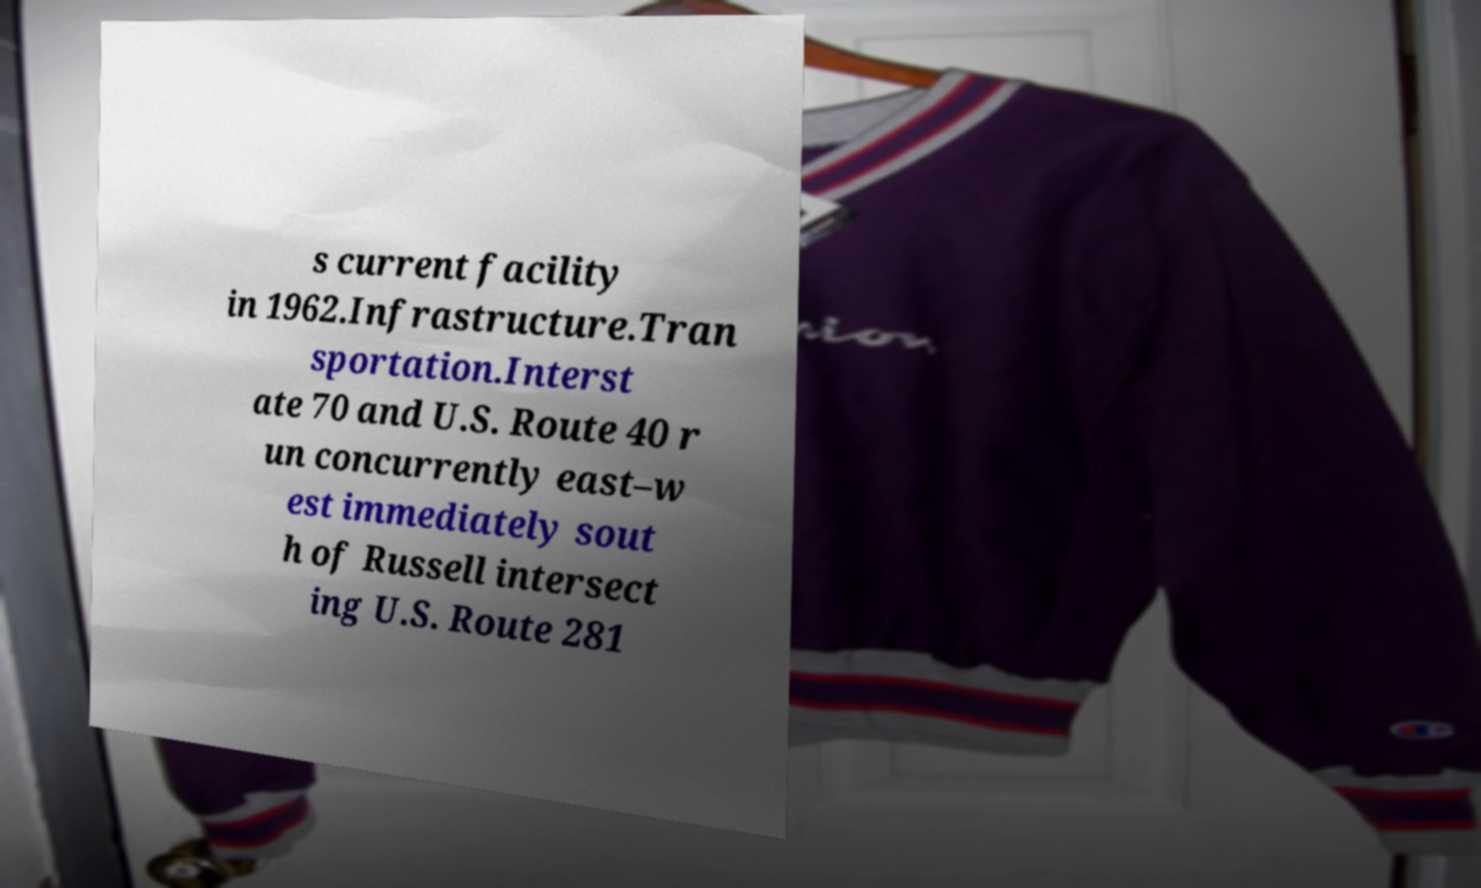Could you assist in decoding the text presented in this image and type it out clearly? s current facility in 1962.Infrastructure.Tran sportation.Interst ate 70 and U.S. Route 40 r un concurrently east–w est immediately sout h of Russell intersect ing U.S. Route 281 